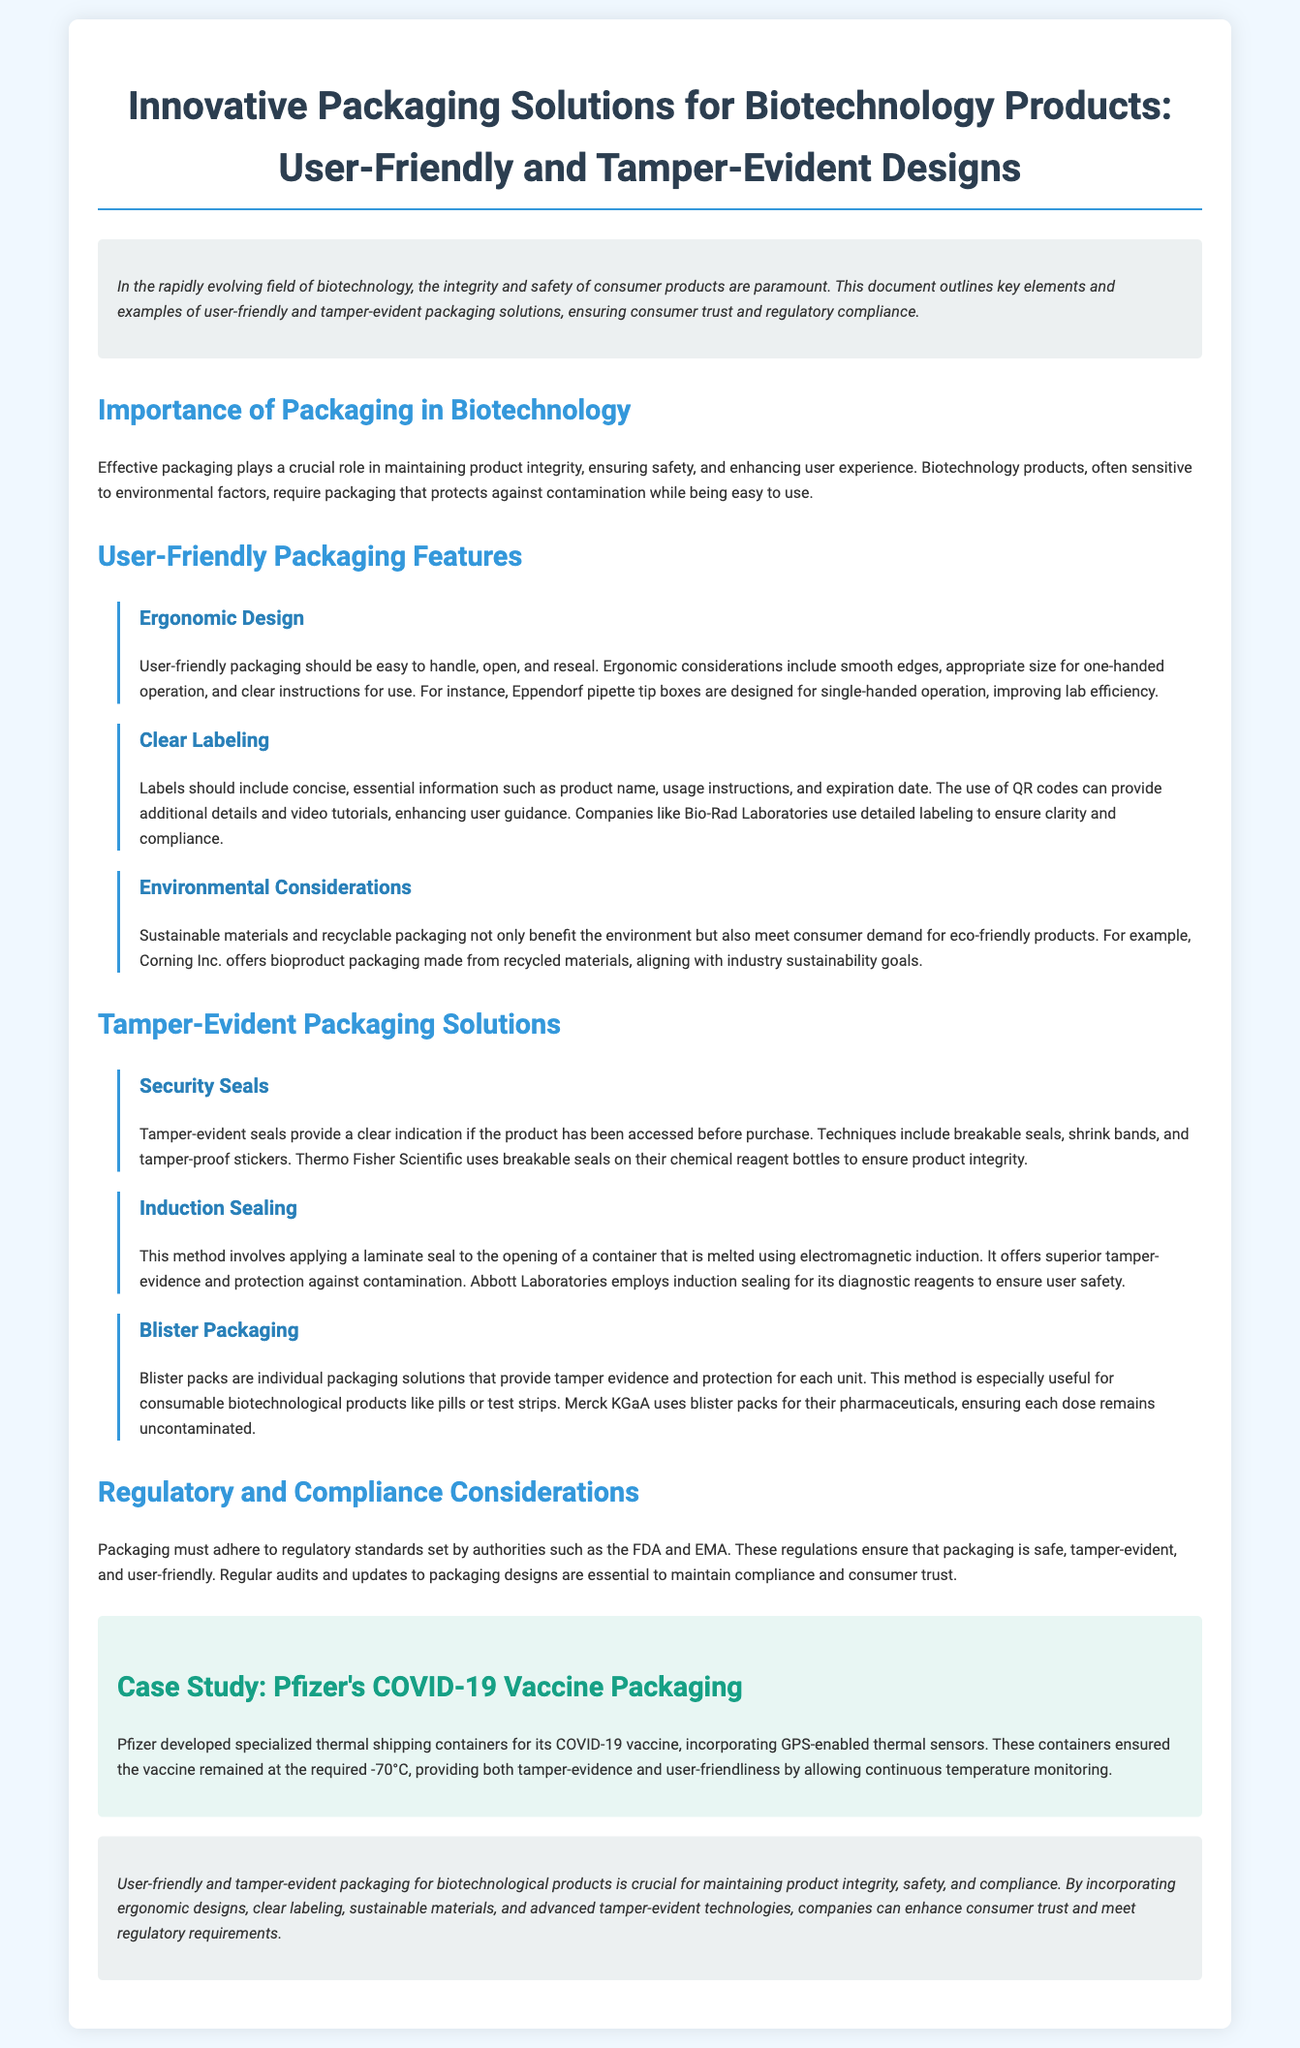What is the primary focus of the document? The document focuses on innovative packaging solutions for biotechnology products, specifically user-friendly and tamper-evident designs.
Answer: innovative packaging solutions for biotechnology products What is one example of a user-friendly packaging feature? The document mentions ergonomic design as a user-friendly packaging feature that includes smooth edges and clear instructions for use.
Answer: ergonomic design Which company uses breakable seals for tamper evidence? The document states that Thermo Fisher Scientific uses breakable seals on their chemical reagent bottles to ensure product integrity.
Answer: Thermo Fisher Scientific What packaging method offers superior tamper-evidence by using electromagnetic induction? The document specifies that induction sealing is a method providing superior tamper-evidence by applying a laminate seal with electromagnetic induction.
Answer: induction sealing What is a regulatory body mentioned that oversees packaging standards? The document mentions the FDA and EMA as regulatory authorities that set packaging standards in the biotechnology field.
Answer: FDA and EMA How does Pfizer ensure temperature monitoring for its COVID-19 vaccine packaging? The document highlights that Pfizer developed specialized thermal shipping containers with GPS-enabled thermal sensors for continuous temperature monitoring.
Answer: GPS-enabled thermal sensors Which company offers bioproduct packaging made from recycled materials? The document indicates that Corning Inc. provides bioproduct packaging made from recycled materials.
Answer: Corning Inc What is the purpose of clear labeling in user-friendly packaging? The document states that clear labeling provides concise, essential information such as product name and usage instructions to enhance user guidance.
Answer: enhance user guidance What type of packaging is particularly useful for consumable biotechnological products? The document notes that blister packaging is especially useful for consumable biotechnological products like pills or test strips.
Answer: blister packaging 